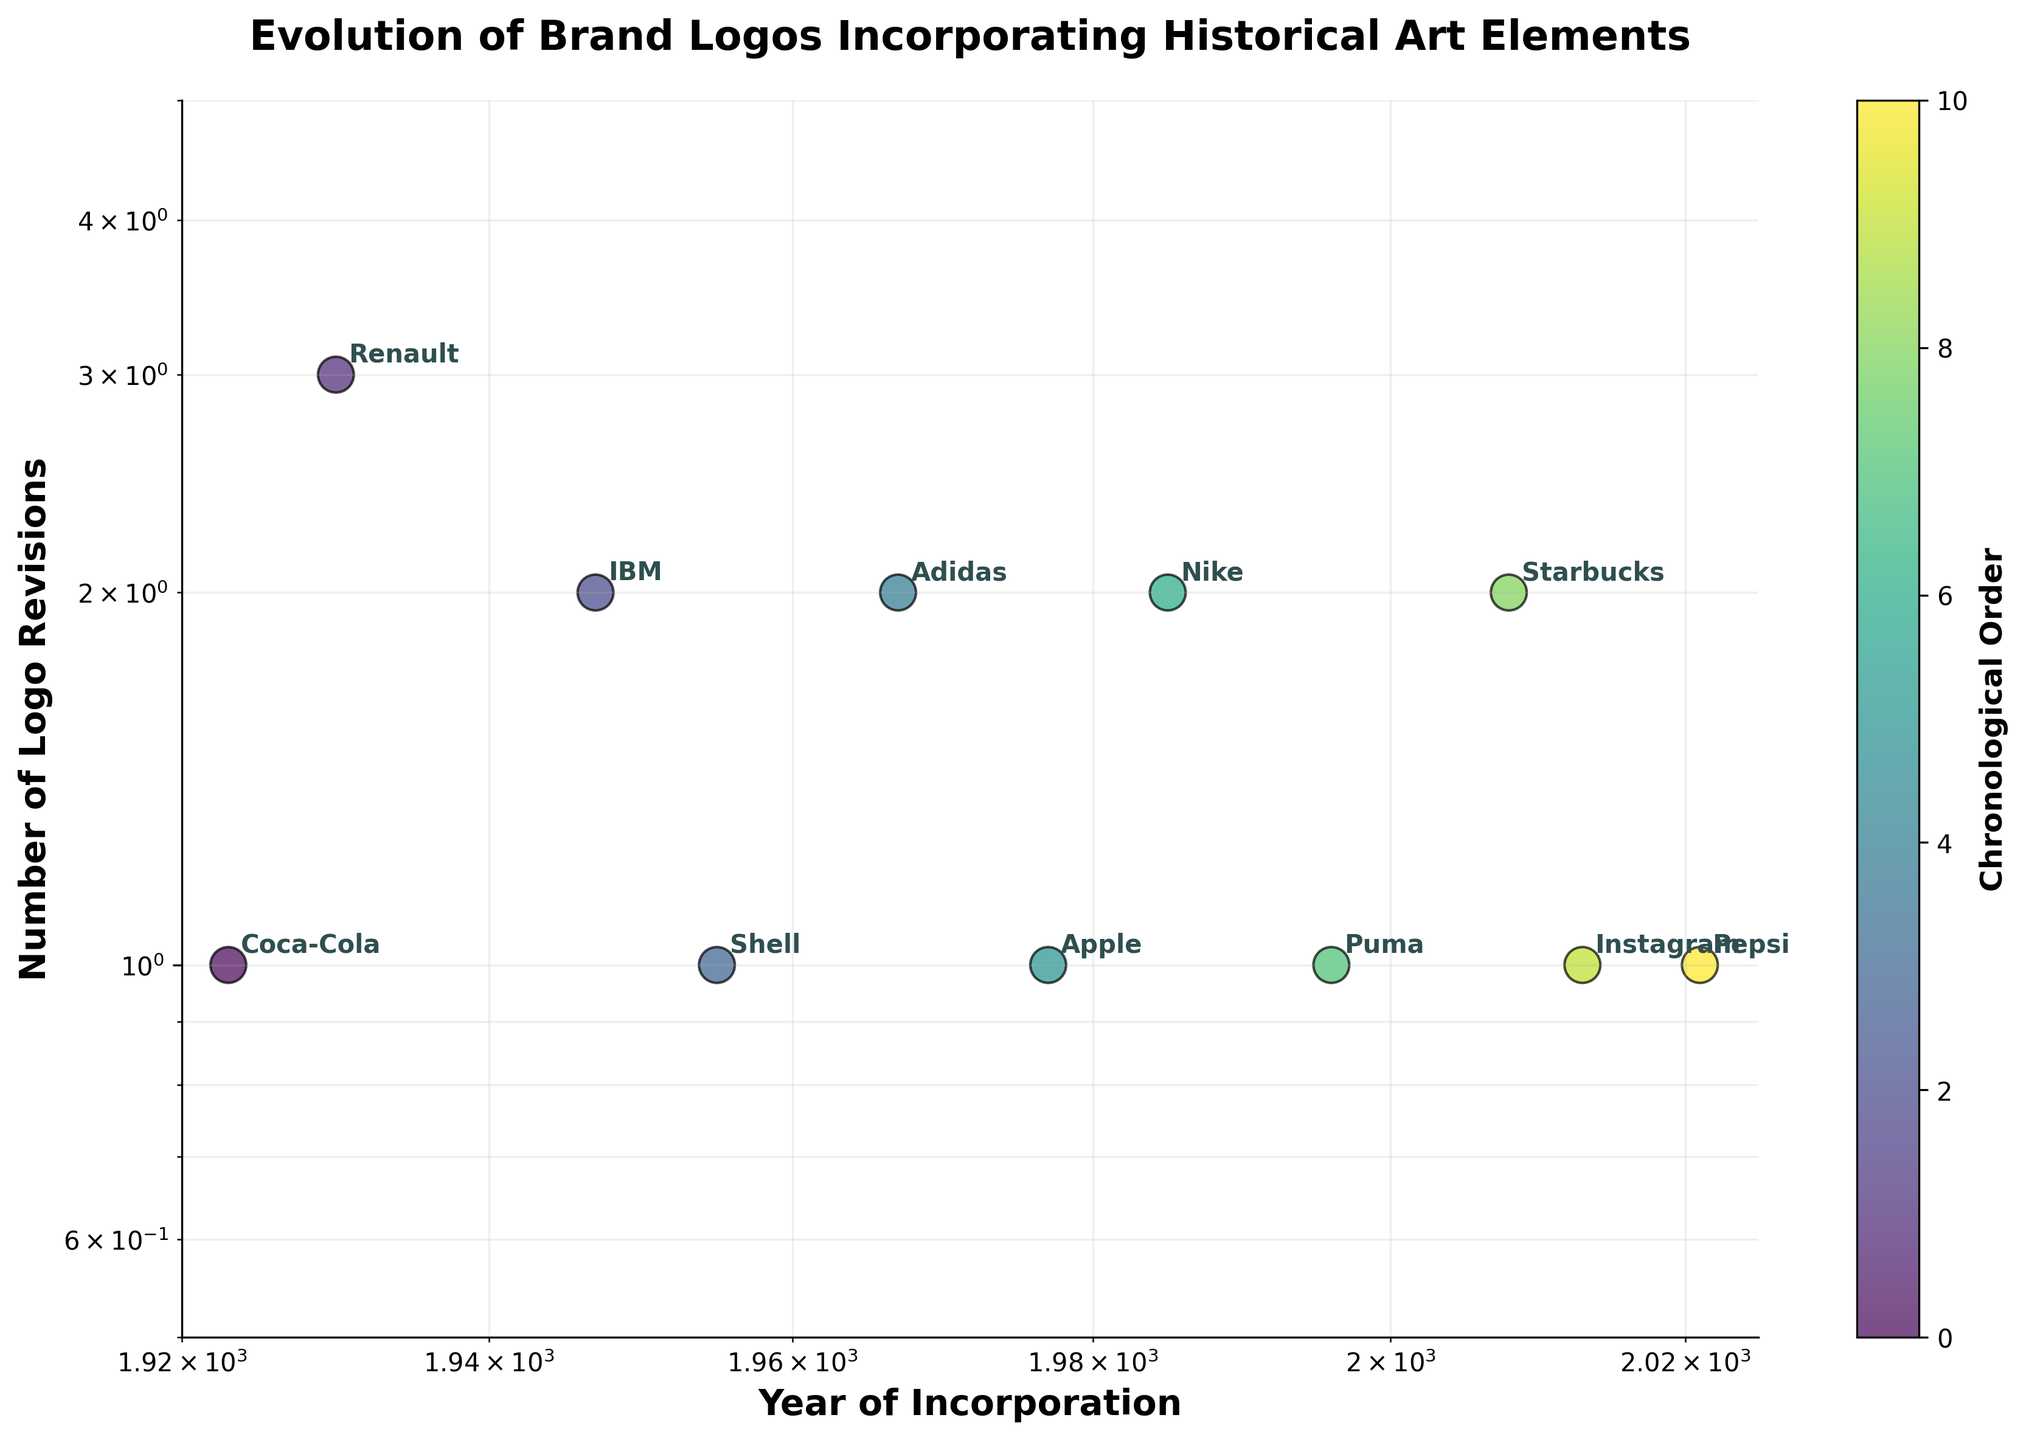How many logos underwent revisions in the 1980s? According to the plot, there is one data point with the year of incorporation in the 1980s, which is Nike in 1985, and the y-axis shows 2 revisions. Thus, only one logo underwent revisions in the 1980s.
Answer: 1 Which brand incorporated elements of the Futurism movement? Look at the annotations on the plot, and identify the label associated with the 1970s decade. The brand with the Futurism influence is Apple, as it is the only brand listed in the 1970s.
Answer: Apple What's the difference in the number of logo revisions between Coca-Cola and IBM? Locate Coca-Cola and IBM on the plot. Coca-Cola is labeled in the 1920s with 1 revision, and IBM in the 1940s with 2 revisions. The difference in the number of revisions is \( 2 - 1 = 1 \).
Answer: 1 Which brand's logo revisions are closest to the upper limit of the y-axis? The plot's upper limit on the y-axis is 5. Identify the data point closest to this limit. Renault, in the 1930s, revised 3 times which is closest to the upper limit of 5.
Answer: Renault What is the range of years during which the brands incorporated historical art elements? The x-axis shows the years of incorporation. Identify the minimum and maximum years marked on the x-axis. The range starts from 1923 to 2021. The range of years is \( 2021 - 1923 \).
Answer: 98 How many brands have only 1 logo revision? Look at the vertical position of the data points representing 1 revision which lies on the y-axis value of 1. Count the brands at this position which are Coca-Cola, Shell, Apple, Puma, Instagram, and Pepsi, totaling 6 brands.
Answer: 6 Which decade had the most varied art movements influencing the logos? Identify the unique art movements listed by each decade. The 1980s show the most varied influences with three different brands, namely, Postmodernism.
Answer: 1980s Which brand shows the smallest number of revisions for the Pop Art movement? Look for the brand associated with Pop Art. Adidas in the 1960s had Pop Art influences, with 2 revisions shown in the log scale plot – the least among brands with this movement.
Answer: Adidas What is the median number of logo revisions for the brands on the plot? List all numbers of revisions: 1, 1, 2, 1, 2, 1, 2, 1, 2, 1, 1. Sort: 1, 1, 1, 1, 1, 1, 2, 2, 2, 2, 2. The middle value is the 6th number in the list, which is 1.
Answer: 1 How does the number of revisions for Instagram compare to that of Starbucks? Locate Instagram (2010s) and Starbucks (2000s). Instagram had 1 revision, and Starbucks had 2 revisions. Instagram's revisions are less compared to Starbucks.
Answer: Less 